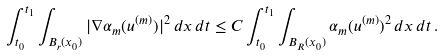Convert formula to latex. <formula><loc_0><loc_0><loc_500><loc_500>\int _ { t _ { 0 } } ^ { t _ { 1 } } \int _ { B _ { r } ( x _ { 0 } ) } | \nabla \alpha _ { m } ( u ^ { ( m ) } ) | ^ { 2 } \, d x \, d t \leq C \int _ { t _ { 0 } } ^ { t _ { 1 } } \int _ { B _ { R } ( x _ { 0 } ) } \alpha _ { m } ( u ^ { ( m ) } ) ^ { 2 } \, d x \, d t \, .</formula> 